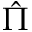<formula> <loc_0><loc_0><loc_500><loc_500>\hat { \Pi }</formula> 